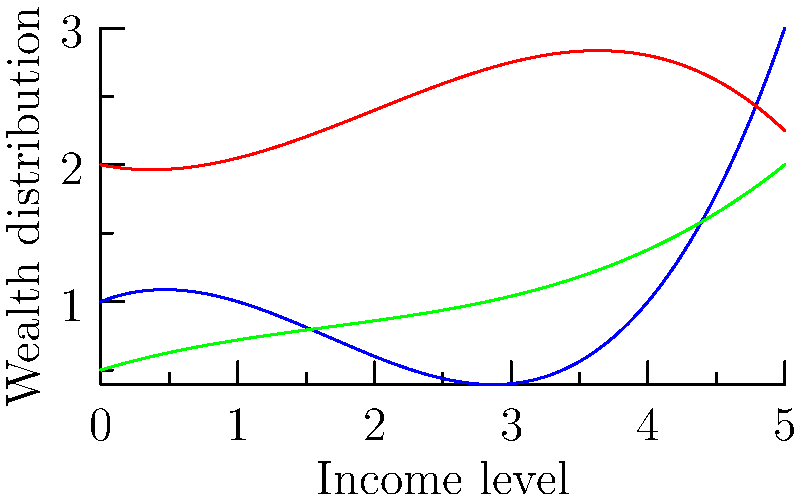The graph above represents the distribution of wealth across different social classes using polynomial curves. Which class experiences the most rapid increase in wealth as income levels rise, and what does this suggest about wealth inequality in capitalist societies? To answer this question, we need to analyze the behavior of each curve:

1. Blue curve (Upper class): This curve has the steepest upward trajectory, especially at higher income levels. The function is of the form $f(x) = 0.1x^3 - 0.5x^2 + 0.4x + 1$, where the positive cubic term dominates at higher values of x.

2. Red curve (Middle class): This curve shows moderate growth but plateaus and then decreases at higher income levels. Its function is $f(x) = -0.05x^3 + 0.3x^2 - 0.2x + 2$.

3. Green curve (Lower class): This curve shows the slowest growth and remains relatively flat. Its function is $f(x) = 0.02x^3 - 0.1x^2 + 0.3x + 0.5$.

The upper class curve (blue) shows the most rapid increase in wealth as income levels rise. This is evident from its steep upward trajectory, especially at higher income levels.

This rapid increase for the upper class suggests:

1. Wealth concentration: As income increases, wealth accumulates more quickly for the upper class than for other classes.

2. Increasing inequality: The gap between the upper class and other classes widens as income levels rise.

3. Compounding advantages: Higher initial wealth likely leads to more opportunities for wealth growth, creating a feedback loop.

This pattern aligns with critiques of capitalism that argue it tends to concentrate wealth at the top, potentially exacerbating social and economic inequalities.
Answer: Upper class; suggests increasing wealth concentration and inequality in capitalist societies. 